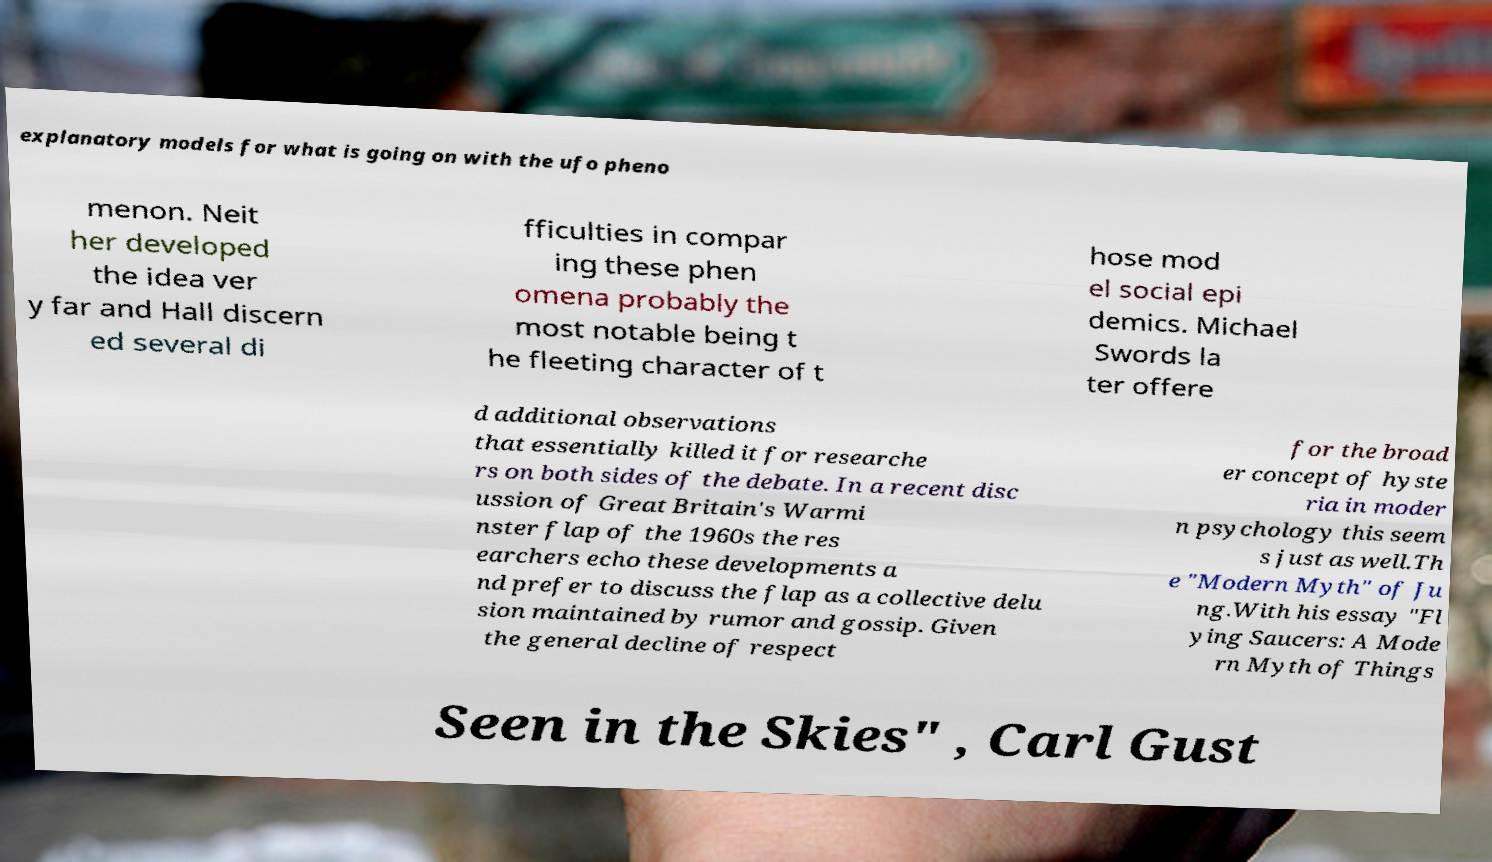Please read and relay the text visible in this image. What does it say? explanatory models for what is going on with the ufo pheno menon. Neit her developed the idea ver y far and Hall discern ed several di fficulties in compar ing these phen omena probably the most notable being t he fleeting character of t hose mod el social epi demics. Michael Swords la ter offere d additional observations that essentially killed it for researche rs on both sides of the debate. In a recent disc ussion of Great Britain's Warmi nster flap of the 1960s the res earchers echo these developments a nd prefer to discuss the flap as a collective delu sion maintained by rumor and gossip. Given the general decline of respect for the broad er concept of hyste ria in moder n psychology this seem s just as well.Th e "Modern Myth" of Ju ng.With his essay "Fl ying Saucers: A Mode rn Myth of Things Seen in the Skies" , Carl Gust 